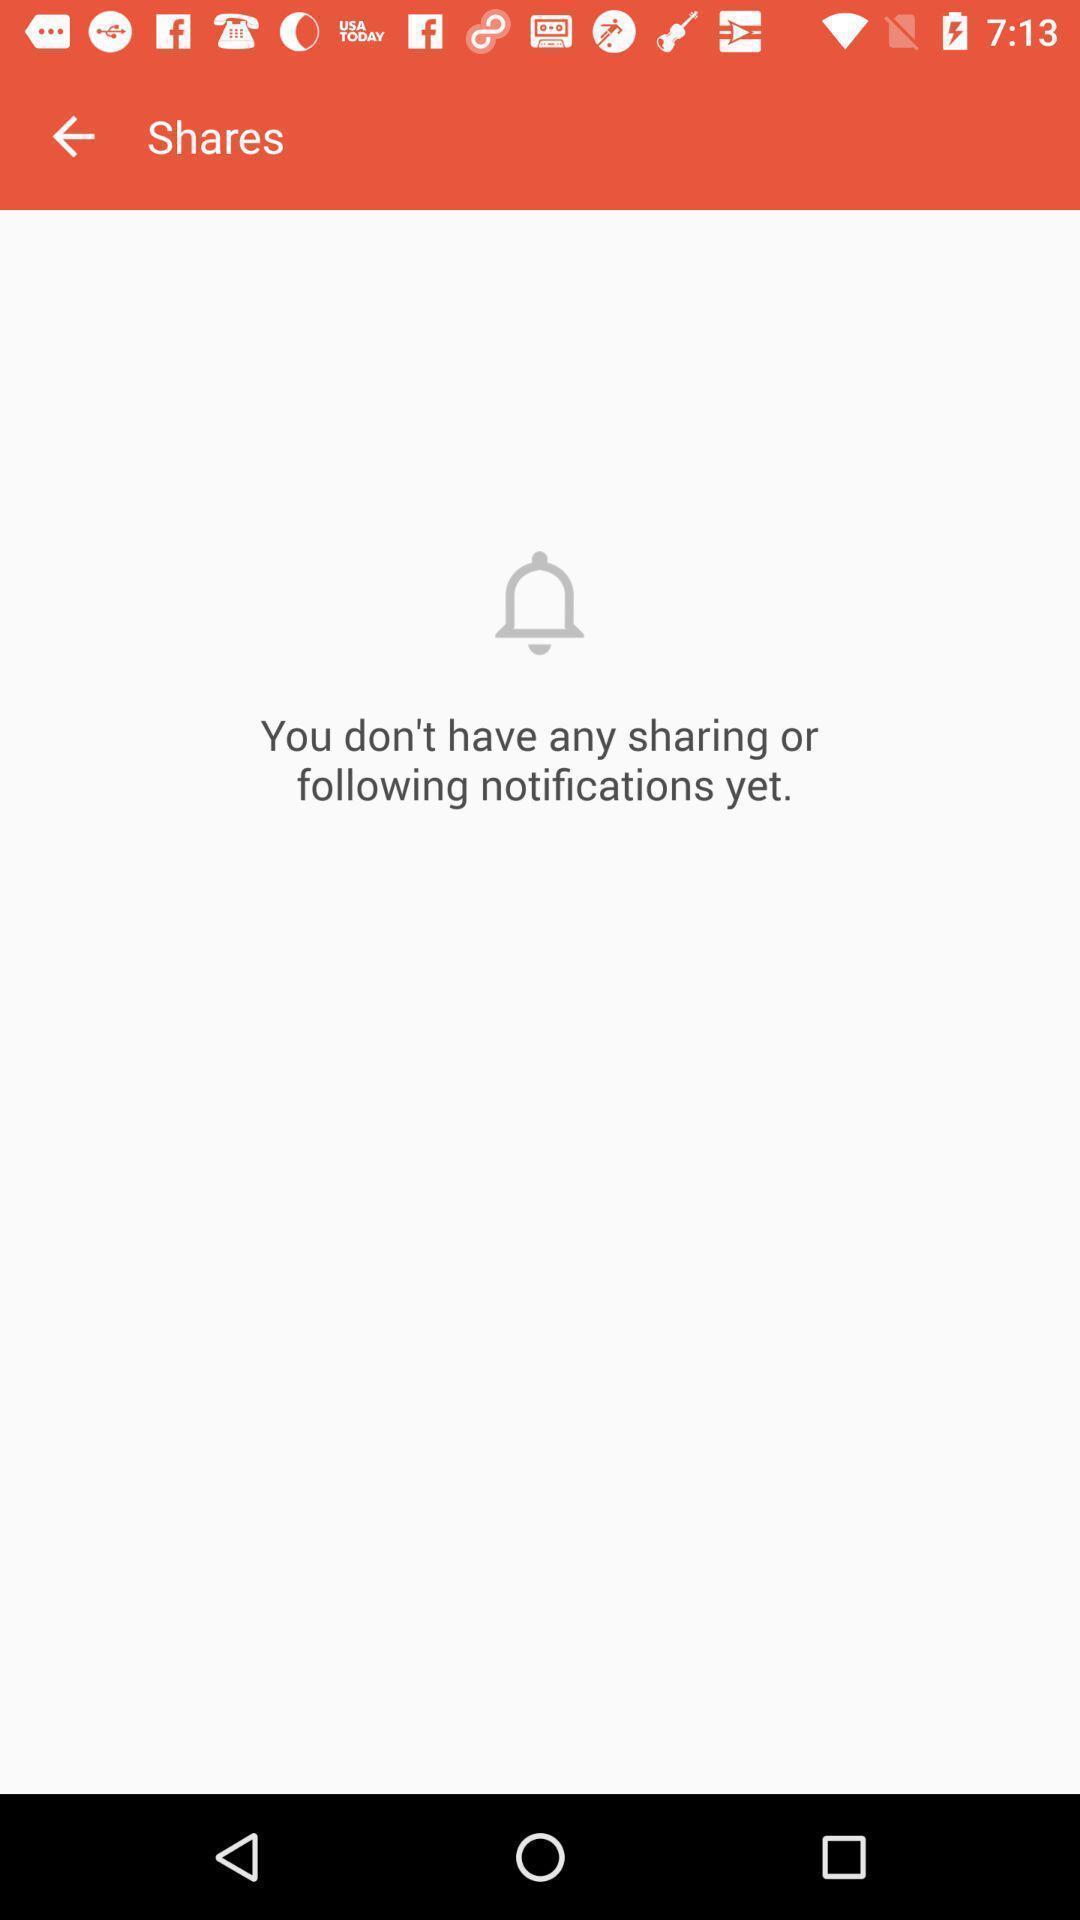Summarize the information in this screenshot. Screen display shares page. 